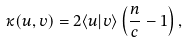<formula> <loc_0><loc_0><loc_500><loc_500>\kappa ( u , v ) = 2 \langle u | v \rangle \left ( \frac { n } { c } - 1 \right ) ,</formula> 